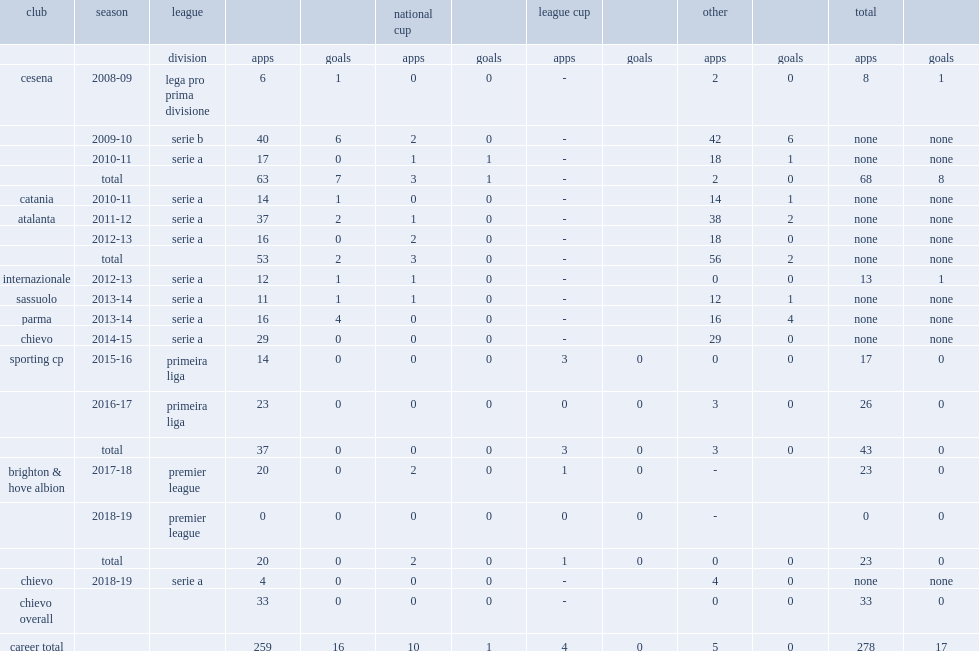Which club did ezequiel schelotto play for in 2011-12? Atalanta. 